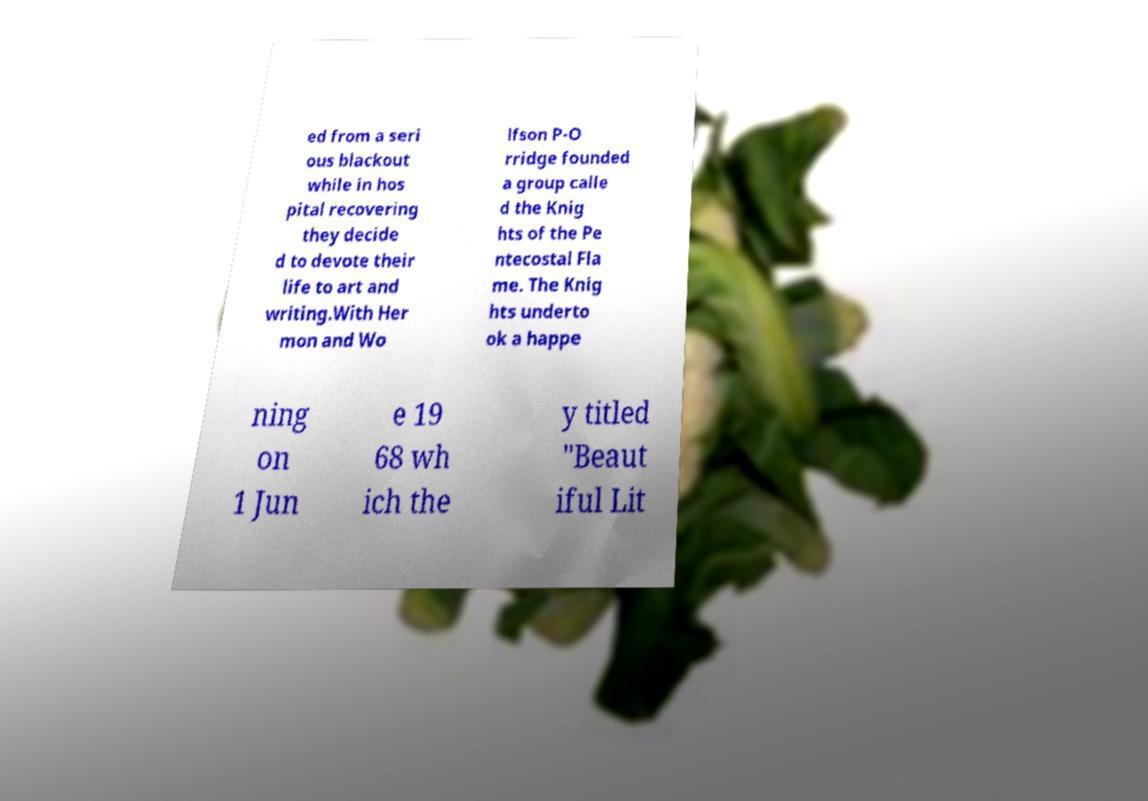What messages or text are displayed in this image? I need them in a readable, typed format. ed from a seri ous blackout while in hos pital recovering they decide d to devote their life to art and writing.With Her mon and Wo lfson P-O rridge founded a group calle d the Knig hts of the Pe ntecostal Fla me. The Knig hts underto ok a happe ning on 1 Jun e 19 68 wh ich the y titled "Beaut iful Lit 